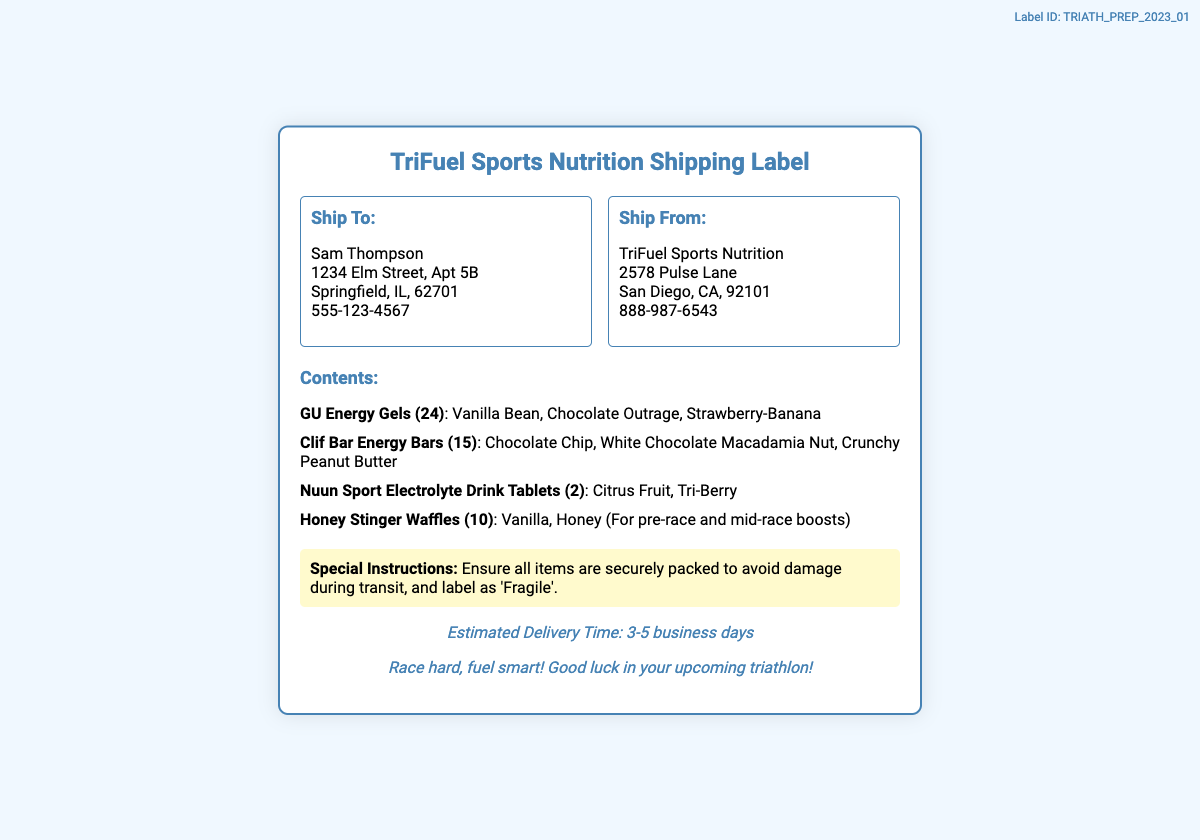What is the label ID? The label ID is located at the top right corner of the document, which uniquely identifies this shipping label.
Answer: TRIATH_PREP_2023_01 Who is the recipient? The recipient's name is presented at the beginning of the shipping address section, indicating who is receiving the package.
Answer: Sam Thompson How many GU Energy Gels are included? The number can be found in the contents list next to the product name, indicating the quantity shipped.
Answer: 24 What is the estimated delivery time? This information is provided in the footer, giving an expected timeframe for when the package will arrive.
Answer: 3-5 business days What is one of the special instructions? Special instructions are outlined in a separate section, indicating specific handling requirements for the shipping process.
Answer: Ensure all items are securely packed What are the flavors of the Honey Stinger Waffles? The flavors are listed in the contents section, providing details about the specific varieties included in the shipment.
Answer: Vanilla, Honey How many Clif Bar Energy Bars are there? The total number of bars is mentioned in parentheses next to the product name in the contents list.
Answer: 15 What company is shipping the items? The shipping company's name is found in the 'Ship From' section of the address block.
Answer: TriFuel Sports Nutrition How many flavors of Nuun Sport Electrolyte Drink Tablets are included? The flavors are mentioned alongside the quantity in the contents section, indicating the variety provided.
Answer: 2 